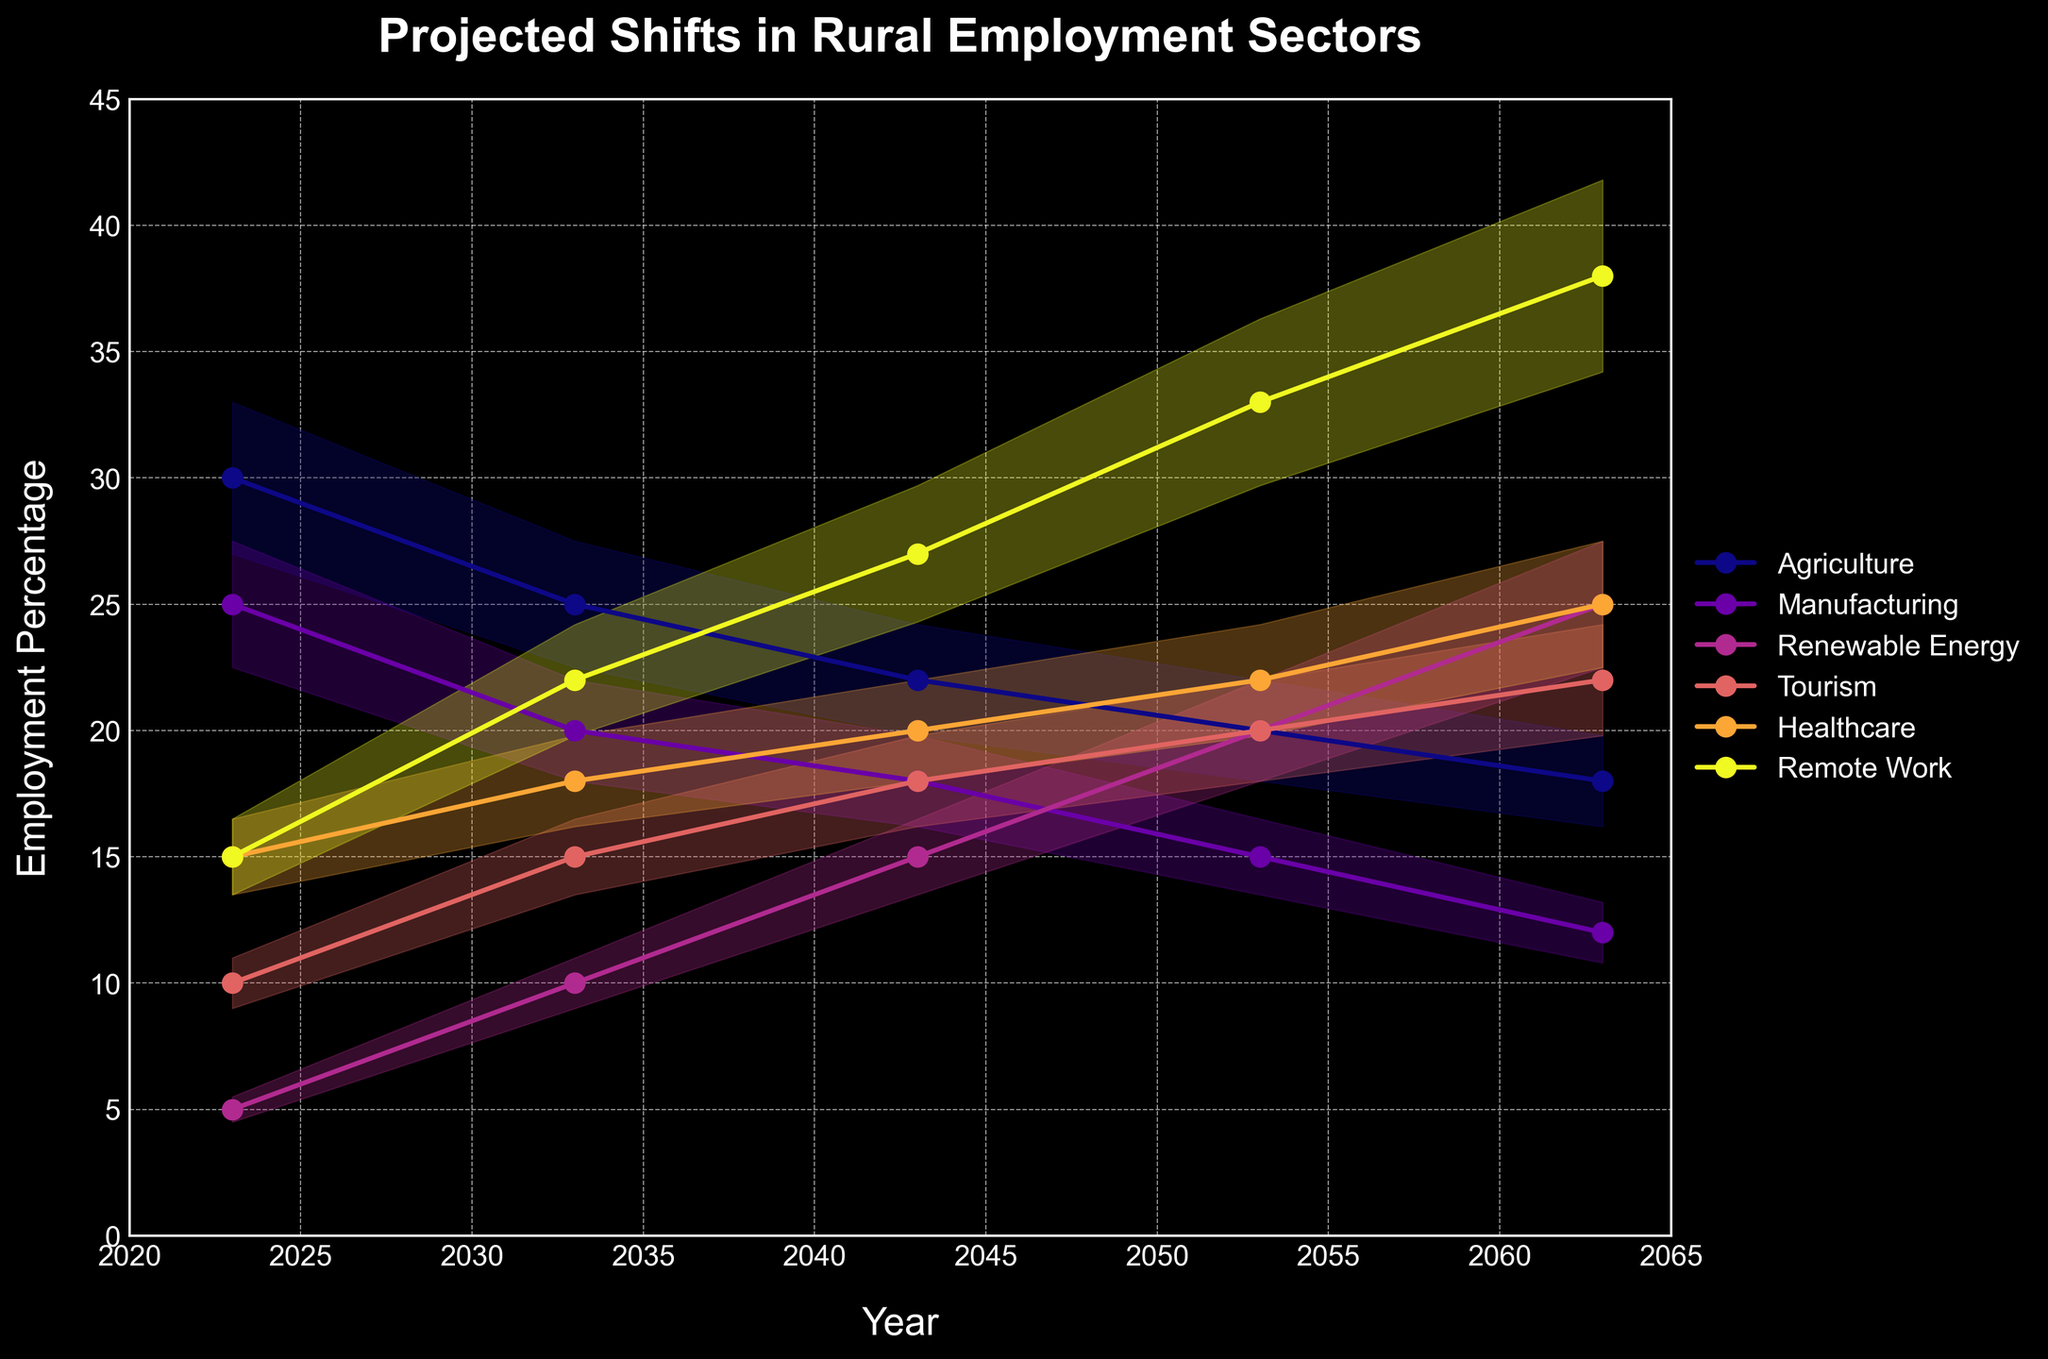What's the title of the figure? The title of the figure appears prominently at the top and is stated in bold and capital letters.
Answer: Projected Shifts in Rural Employment Sectors What are the industries represented in the chart? The industries are listed in the legend on the right-hand side of the chart. They are Agriculture, Manufacturing, Renewable Energy, Tourism, Healthcare, and Remote Work.
Answer: Agriculture, Manufacturing, Renewable Energy, Tourism, Healthcare, Remote Work What's the projected employment percentage in Agriculture for the year 2033? By observing the yellow line (representing Agriculture) at the year 2033, the value is clearly marked with a data point.
Answer: 25 How does the projected percentage change in Healthcare between 2043 and 2063? First locate Healthcare (represented by the purple line) at 2043 and 2063, then find the difference in their values (25% - 20%).
Answer: Increases by 5% Which industry shows the most significant growth from 2023 to 2063? By comparing the lines, Renewable Energy (represented by the green line) shows the most significant increase from 5% in 2023 to 25% in 2063.
Answer: Renewable Energy In what year does Remote Work surpass Manufacturing in projected employment percentage? Identify where the Remote Work (teal line) first exceeds the Manufacturing (red line). This occurs around 2033.
Answer: 2033 What is the projected employment percentage for Tourism in the year 2063? By referring to the dark blue line (Tourism) at year 2063, the value is found at the corresponding data point.
Answer: 22 Compare the trend of Agriculture and Remote Work from 2023 to 2063. Which one decreases more rapidly? The yellow line (Agriculture) shows a decline from 30% to 18%, whereas the teal line (Remote Work) increases. The Agriculture line shows a more rapid decrease.
Answer: Agriculture Between what years does Manufacturing's projected employment percentage drop the most? The red line (Manufacturing) has the steepest decline between 2023 and 2033, dropping from 25% to 20%.
Answer: 2023 to 2033 What's the average projected employment percentage for Healthcare across all the years? Add the percentages for Healthcare (15 + 18 + 20 + 22 + 25) and divide by the number of years. (15 + 18 + 20 + 22 + 25) / 5 = 20
Answer: 20 